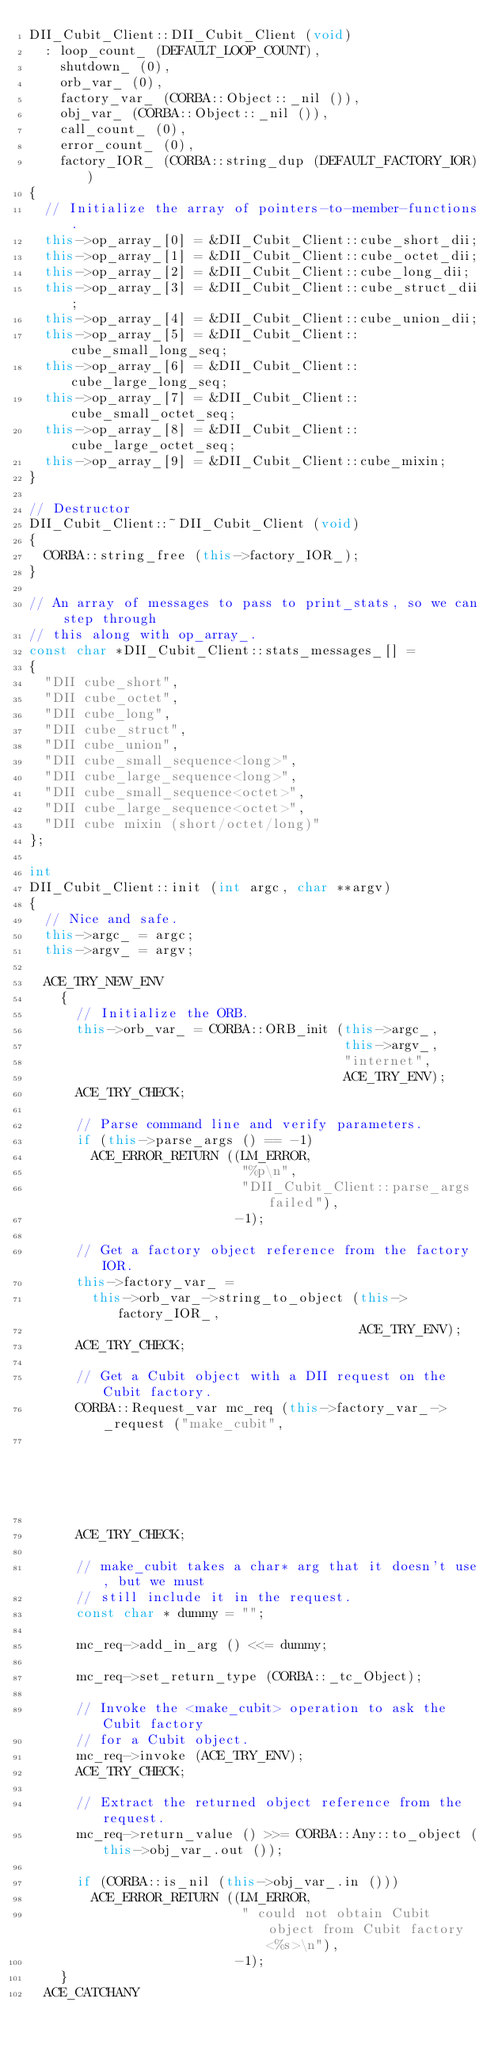<code> <loc_0><loc_0><loc_500><loc_500><_C++_>DII_Cubit_Client::DII_Cubit_Client (void)
  : loop_count_ (DEFAULT_LOOP_COUNT),
    shutdown_ (0),
    orb_var_ (0),
    factory_var_ (CORBA::Object::_nil ()),
    obj_var_ (CORBA::Object::_nil ()),
    call_count_ (0),
    error_count_ (0),
    factory_IOR_ (CORBA::string_dup (DEFAULT_FACTORY_IOR))
{
  // Initialize the array of pointers-to-member-functions.
  this->op_array_[0] = &DII_Cubit_Client::cube_short_dii;
  this->op_array_[1] = &DII_Cubit_Client::cube_octet_dii;
  this->op_array_[2] = &DII_Cubit_Client::cube_long_dii;
  this->op_array_[3] = &DII_Cubit_Client::cube_struct_dii;
  this->op_array_[4] = &DII_Cubit_Client::cube_union_dii;
  this->op_array_[5] = &DII_Cubit_Client::cube_small_long_seq;
  this->op_array_[6] = &DII_Cubit_Client::cube_large_long_seq;
  this->op_array_[7] = &DII_Cubit_Client::cube_small_octet_seq;
  this->op_array_[8] = &DII_Cubit_Client::cube_large_octet_seq;
  this->op_array_[9] = &DII_Cubit_Client::cube_mixin;
}

// Destructor
DII_Cubit_Client::~DII_Cubit_Client (void)
{
  CORBA::string_free (this->factory_IOR_);
}

// An array of messages to pass to print_stats, so we can step through
// this along with op_array_.
const char *DII_Cubit_Client::stats_messages_[] =
{
  "DII cube_short",
  "DII cube_octet",
  "DII cube_long",
  "DII cube_struct",
  "DII cube_union",
  "DII cube_small_sequence<long>",
  "DII cube_large_sequence<long>",
  "DII cube_small_sequence<octet>",
  "DII cube_large_sequence<octet>",
  "DII cube mixin (short/octet/long)"
};

int
DII_Cubit_Client::init (int argc, char **argv)
{
  // Nice and safe.
  this->argc_ = argc;
  this->argv_ = argv;

  ACE_TRY_NEW_ENV
    {
      // Initialize the ORB.
      this->orb_var_ = CORBA::ORB_init (this->argc_,
                                        this->argv_,
                                        "internet",
                                        ACE_TRY_ENV);
      ACE_TRY_CHECK;

      // Parse command line and verify parameters.
      if (this->parse_args () == -1)
        ACE_ERROR_RETURN ((LM_ERROR,
                           "%p\n",
                           "DII_Cubit_Client::parse_args failed"),
                          -1);

      // Get a factory object reference from the factory IOR.
      this->factory_var_ =
        this->orb_var_->string_to_object (this->factory_IOR_,
                                          ACE_TRY_ENV);
      ACE_TRY_CHECK;

      // Get a Cubit object with a DII request on the Cubit factory.
      CORBA::Request_var mc_req (this->factory_var_->_request ("make_cubit",
                                                               ACE_TRY_ENV));

      ACE_TRY_CHECK;

      // make_cubit takes a char* arg that it doesn't use, but we must
      // still include it in the request.
      const char * dummy = "";

      mc_req->add_in_arg () <<= dummy;

      mc_req->set_return_type (CORBA::_tc_Object);

      // Invoke the <make_cubit> operation to ask the Cubit factory
      // for a Cubit object.
      mc_req->invoke (ACE_TRY_ENV);
      ACE_TRY_CHECK;

      // Extract the returned object reference from the request.
      mc_req->return_value () >>= CORBA::Any::to_object (this->obj_var_.out ());

      if (CORBA::is_nil (this->obj_var_.in ()))
        ACE_ERROR_RETURN ((LM_ERROR,
                           " could not obtain Cubit object from Cubit factory <%s>\n"),
                          -1);
    }
  ACE_CATCHANY</code> 